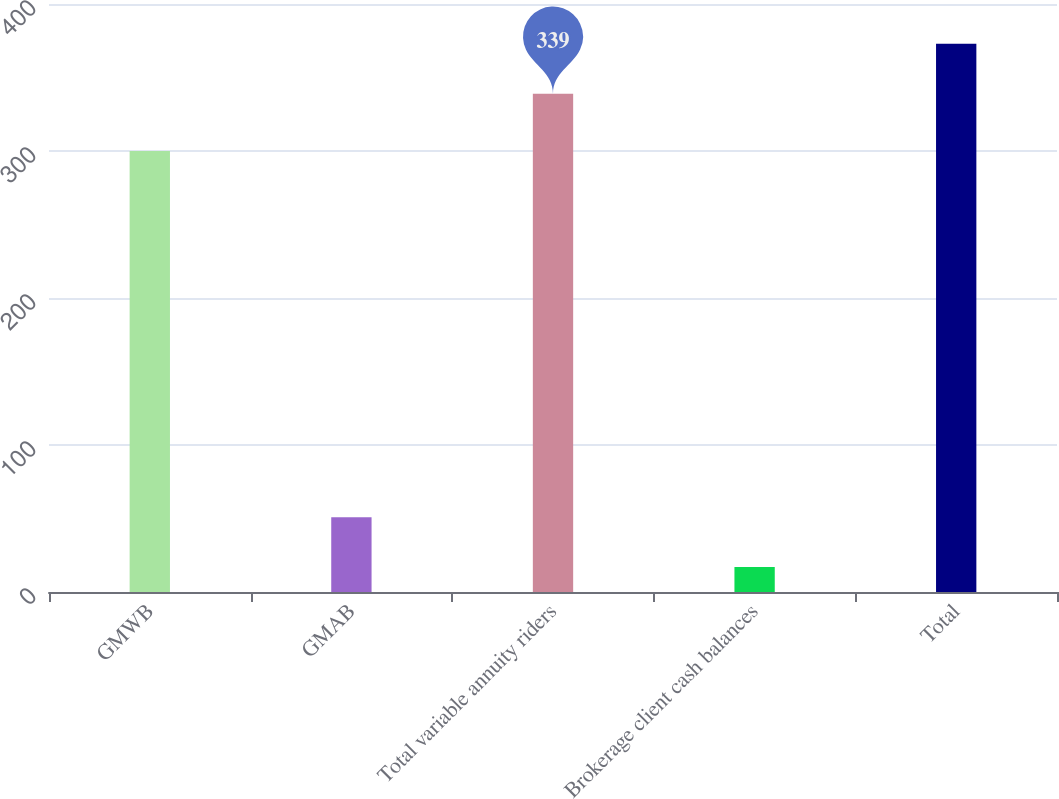Convert chart. <chart><loc_0><loc_0><loc_500><loc_500><bar_chart><fcel>GMWB<fcel>GMAB<fcel>Total variable annuity riders<fcel>Brokerage client cash balances<fcel>Total<nl><fcel>300<fcel>50.9<fcel>339<fcel>17<fcel>372.9<nl></chart> 